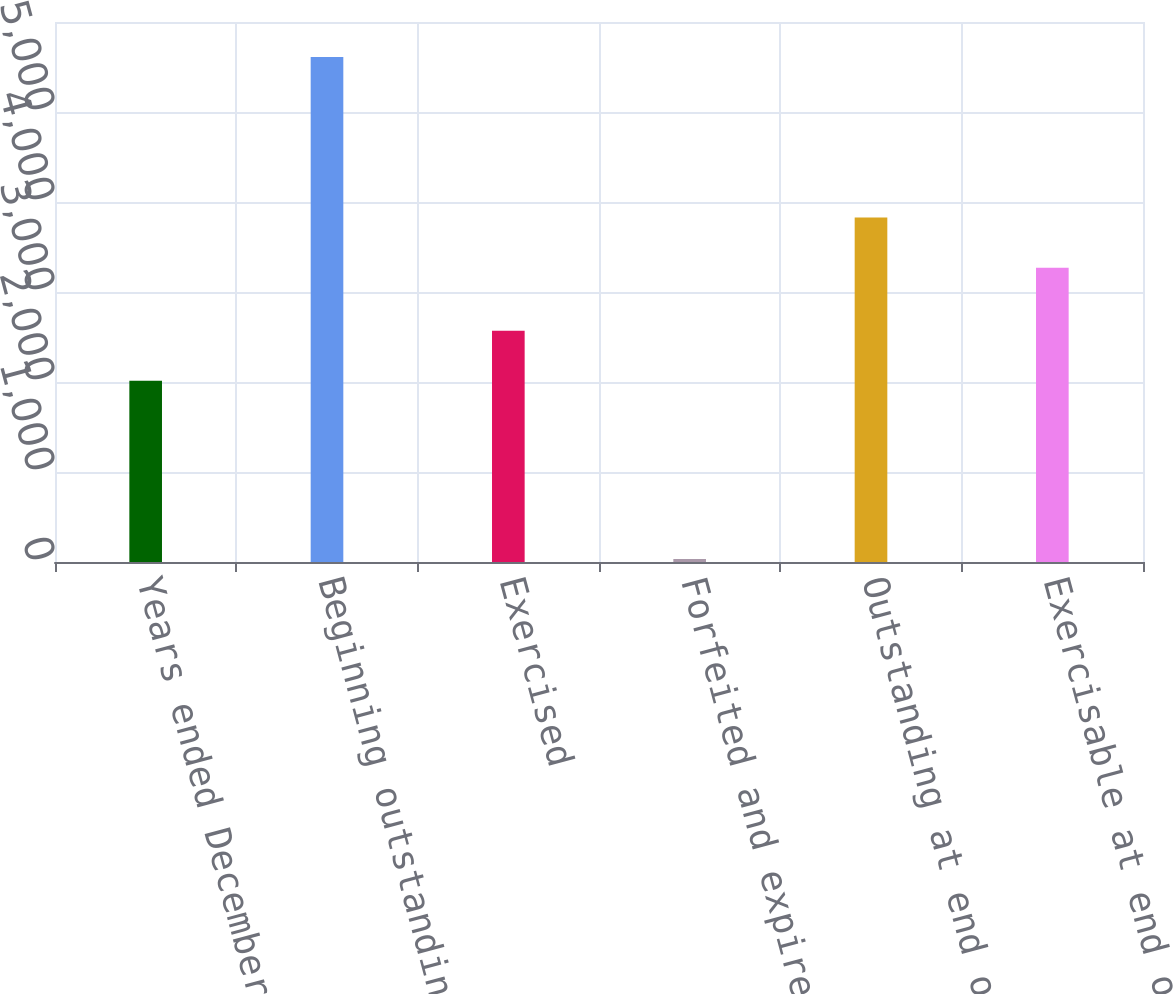<chart> <loc_0><loc_0><loc_500><loc_500><bar_chart><fcel>Years ended December 31<fcel>Beginning outstanding<fcel>Exercised<fcel>Forfeited and expired<fcel>Outstanding at end of year<fcel>Exercisable at end of year<nl><fcel>2013<fcel>5611<fcel>2570.8<fcel>33<fcel>3827.8<fcel>3270<nl></chart> 